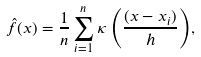Convert formula to latex. <formula><loc_0><loc_0><loc_500><loc_500>\hat { f } ( x ) = \frac { 1 } { n } \sum _ { i = 1 } ^ { n } { \kappa \left ( \frac { ( x - x _ { i } ) } { h } \right ) } ,</formula> 